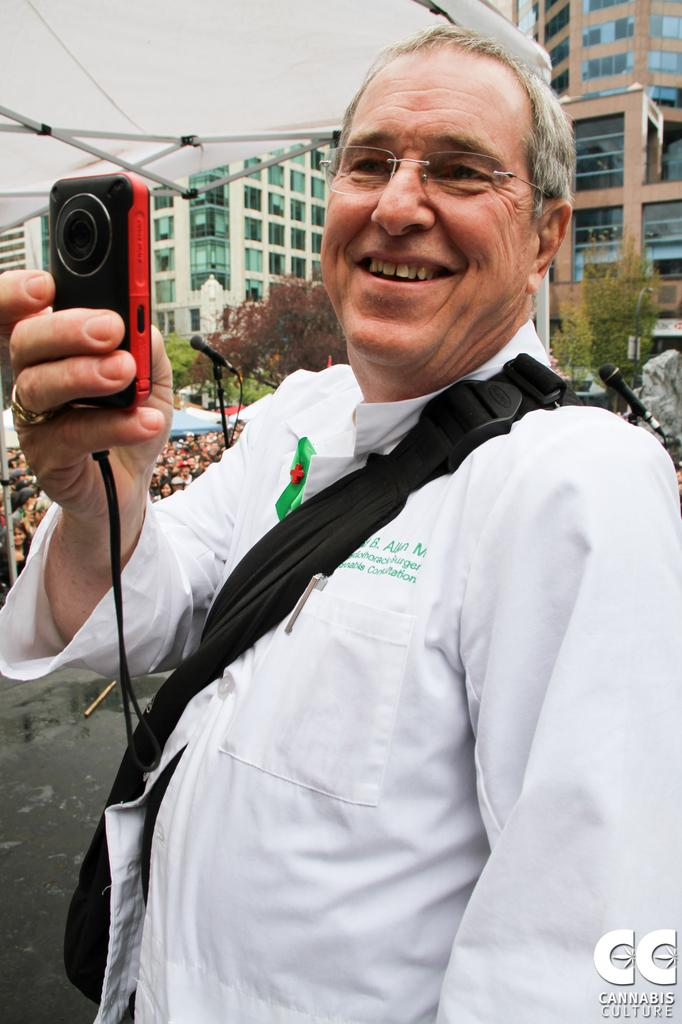What is the main subject of the image? There is a man in the image. What is the man doing in the image? The man is standing and holding a camera in his hand. What is the man's facial expression in the image? The man has a smile on his face. What can be seen in the background of the image? There are buildings and trees visible in the background of the image. What type of song is the man singing in the image? There is no indication in the image that the man is singing, so it cannot be determined from the picture. 